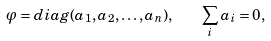Convert formula to latex. <formula><loc_0><loc_0><loc_500><loc_500>\varphi = d i a g ( a _ { 1 } , a _ { 2 } , \dots , a _ { n } ) , \quad \sum _ { i } a _ { i } = 0 ,</formula> 